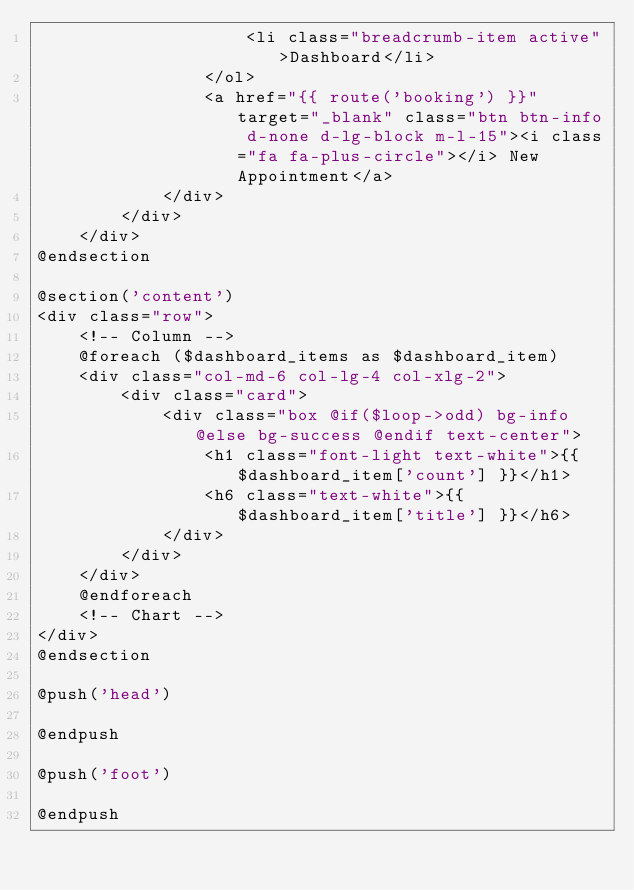Convert code to text. <code><loc_0><loc_0><loc_500><loc_500><_PHP_>                    <li class="breadcrumb-item active">Dashboard</li>
                </ol>
                <a href="{{ route('booking') }}" target="_blank" class="btn btn-info d-none d-lg-block m-l-15"><i class="fa fa-plus-circle"></i> New Appointment</a>
            </div>
        </div>
    </div>
@endsection

@section('content')
<div class="row">
    <!-- Column -->
    @foreach ($dashboard_items as $dashboard_item)
    <div class="col-md-6 col-lg-4 col-xlg-2">
        <div class="card">
            <div class="box @if($loop->odd) bg-info @else bg-success @endif text-center">
                <h1 class="font-light text-white">{{ $dashboard_item['count'] }}</h1>
                <h6 class="text-white">{{ $dashboard_item['title'] }}</h6>
            </div>
        </div>
    </div>
    @endforeach
    <!-- Chart -->
</div>
@endsection

@push('head')

@endpush

@push('foot')

@endpush
</code> 